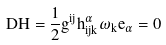<formula> <loc_0><loc_0><loc_500><loc_500>D \vec { H } = \frac { 1 } { 2 } g ^ { i j } h ^ { \alpha } _ { i j k } \omega _ { k } e _ { \alpha } = 0</formula> 